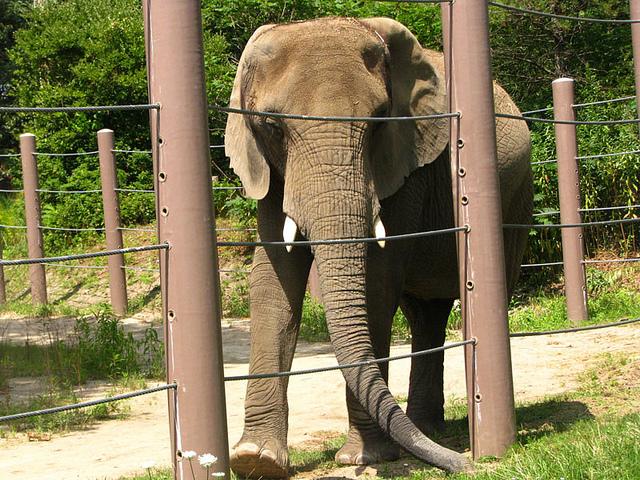How many legs can be seen?
Give a very brief answer. 3. How many poles in front of the elephant?
Concise answer only. 2. Is this animal free roaming?
Short answer required. No. 